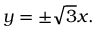<formula> <loc_0><loc_0><loc_500><loc_500>y = \pm { \sqrt { 3 } } x .</formula> 